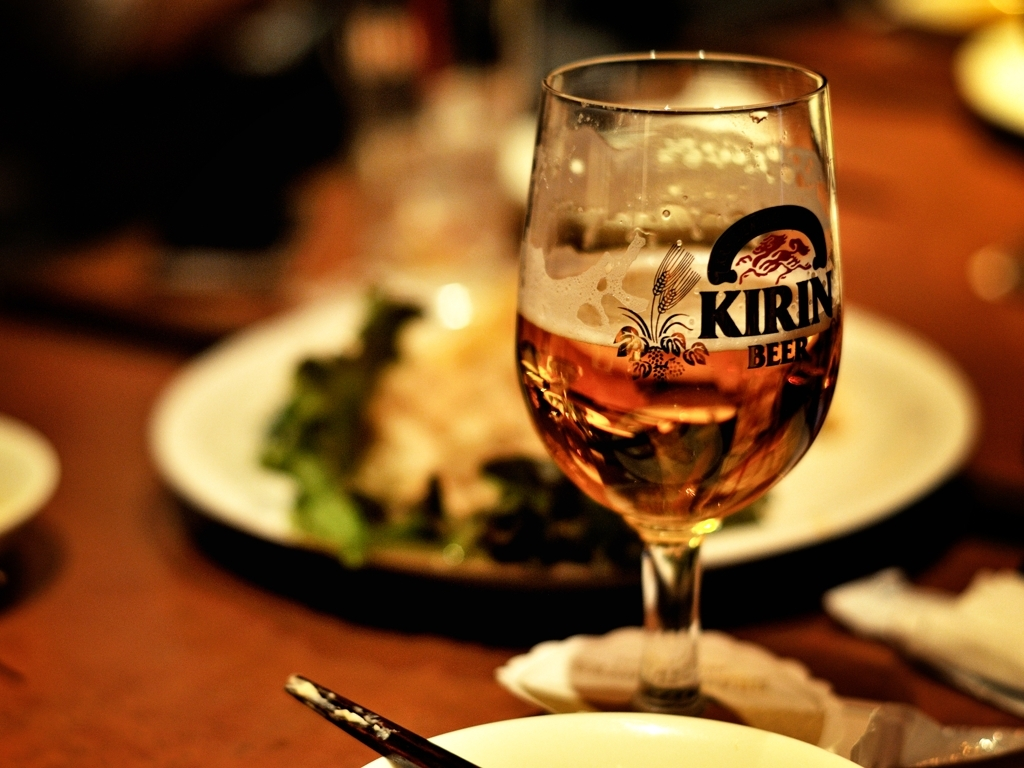Are there any quality issues with this image? Yes, there are a few quality issues. The image appears to be slightly out of focus, particularly in the background, and there's evident noise, possibly due to low lighting conditions. The composition could be improved for a better visual balance, and the foreground subjects could be sharper to enhance the overall appeal. 